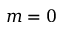Convert formula to latex. <formula><loc_0><loc_0><loc_500><loc_500>m = 0</formula> 